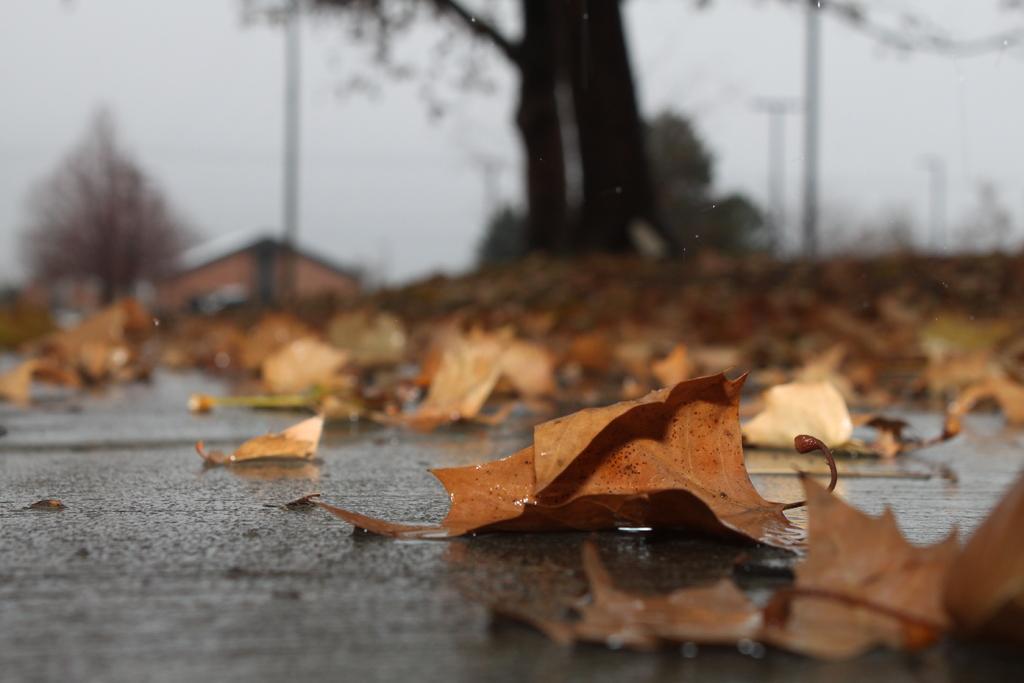Can you describe this image briefly? In this picture I can see leaves on the road, there is a house, trees, and in the background there is sky. 